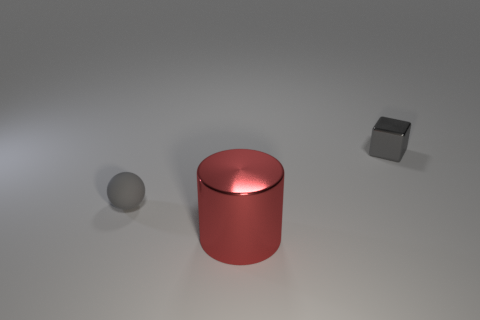How many other things are the same size as the rubber thing?
Offer a terse response. 1. What is the material of the thing that is on the right side of the matte thing and behind the red metallic cylinder?
Your response must be concise. Metal. Is the color of the rubber sphere the same as the shiny object that is right of the red cylinder?
Provide a short and direct response. Yes. There is a thing that is in front of the tiny gray metallic cube and behind the red thing; what shape is it?
Your answer should be very brief. Sphere. There is a gray sphere; is its size the same as the metallic object on the left side of the small gray cube?
Ensure brevity in your answer.  No. Does the gray thing that is behind the small matte thing have the same size as the thing that is on the left side of the big object?
Your answer should be compact. Yes. Is the shape of the red metallic thing the same as the gray matte object?
Your answer should be very brief. No. What number of things are either gray objects that are on the left side of the small cube or large red metal cylinders?
Offer a very short reply. 2. Is there another big red rubber thing of the same shape as the big red object?
Make the answer very short. No. Are there an equal number of small gray rubber spheres that are left of the gray rubber sphere and gray metallic things?
Offer a terse response. No. 